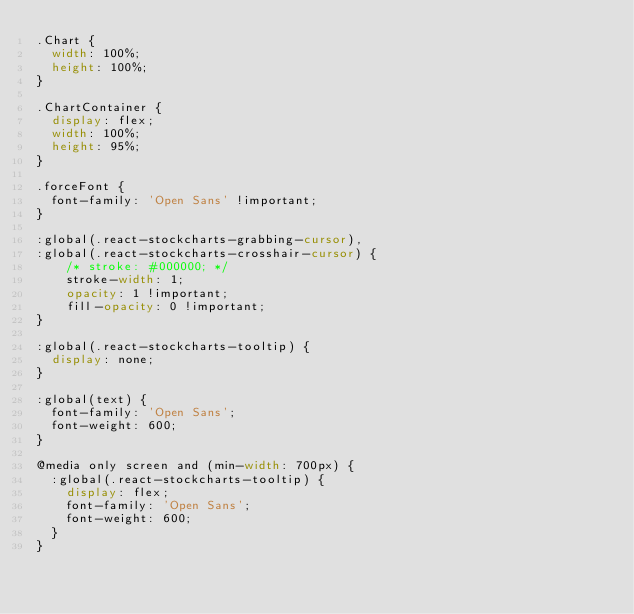Convert code to text. <code><loc_0><loc_0><loc_500><loc_500><_CSS_>.Chart {
  width: 100%;
  height: 100%;
}

.ChartContainer {
  display: flex;
  width: 100%;
  height: 95%;
}

.forceFont {
  font-family: 'Open Sans' !important;
}

:global(.react-stockcharts-grabbing-cursor),
:global(.react-stockcharts-crosshair-cursor) {
	/* stroke: #000000; */
	stroke-width: 1;
	opacity: 1 !important;
	fill-opacity: 0 !important;
}

:global(.react-stockcharts-tooltip) {
  display: none;
}

:global(text) {
  font-family: 'Open Sans';
  font-weight: 600;
}

@media only screen and (min-width: 700px) {
  :global(.react-stockcharts-tooltip) {
    display: flex;
    font-family: 'Open Sans';
    font-weight: 600;  
  }
}

</code> 